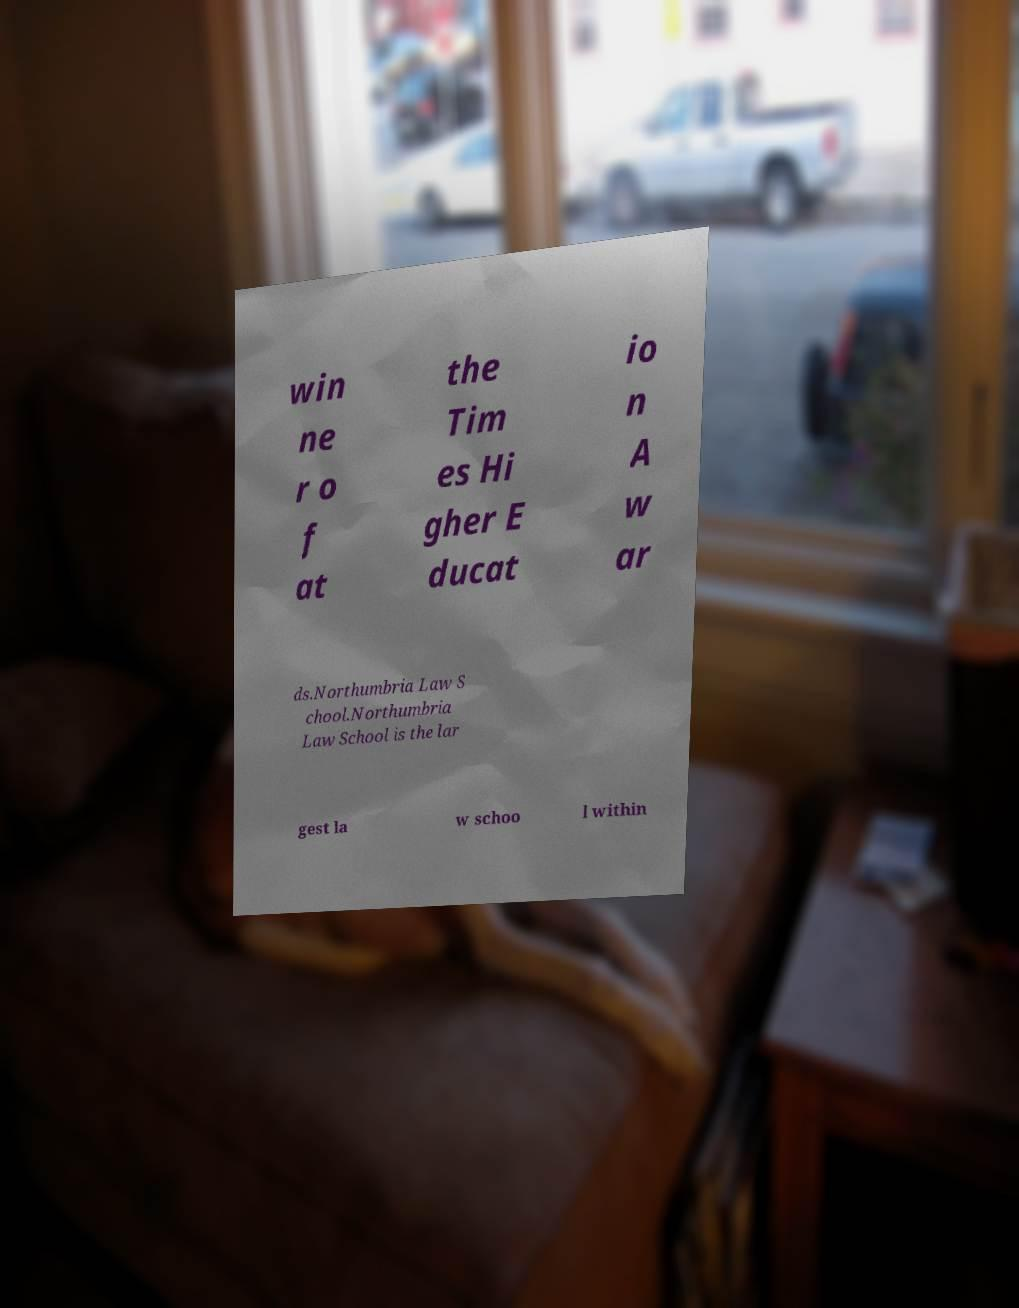I need the written content from this picture converted into text. Can you do that? win ne r o f at the Tim es Hi gher E ducat io n A w ar ds.Northumbria Law S chool.Northumbria Law School is the lar gest la w schoo l within 